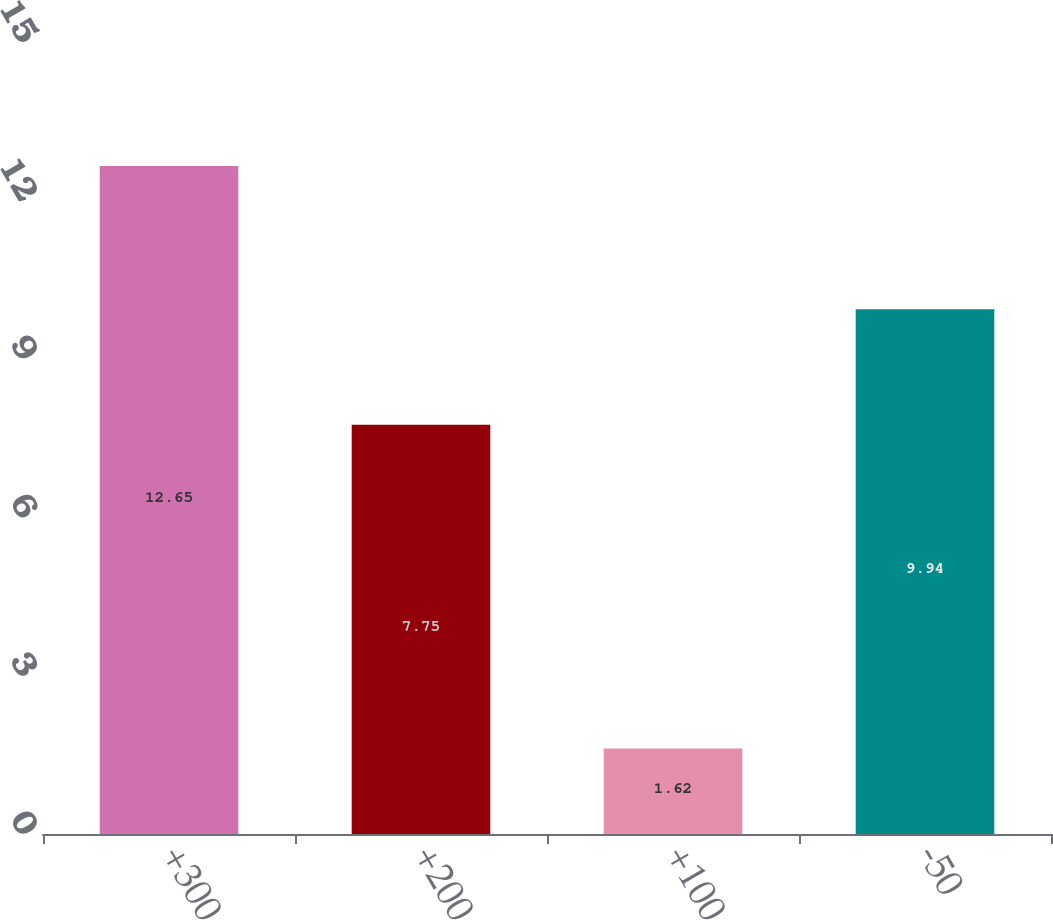Convert chart. <chart><loc_0><loc_0><loc_500><loc_500><bar_chart><fcel>+300<fcel>+200<fcel>+100<fcel>-50<nl><fcel>12.65<fcel>7.75<fcel>1.62<fcel>9.94<nl></chart> 